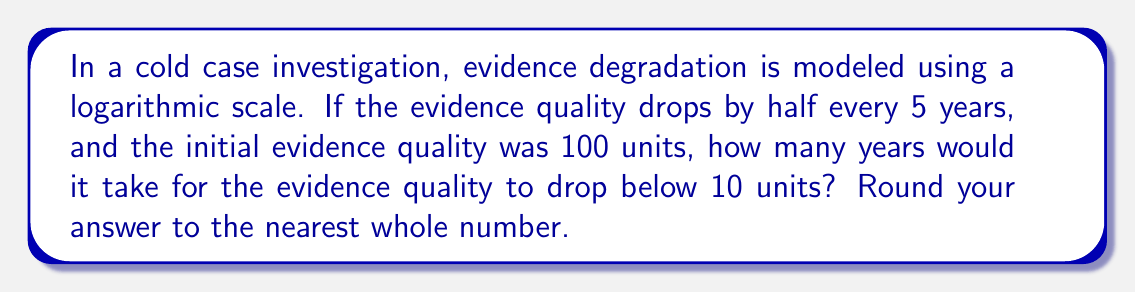Solve this math problem. Let's approach this step-by-step:

1) First, we need to establish our logarithmic model. The general form is:

   $Q(t) = Q_0 \cdot 2^{-t/h}$

   Where $Q(t)$ is the quality at time $t$, $Q_0$ is the initial quality, and $h$ is the half-life.

2) We're given:
   $Q_0 = 100$ (initial quality)
   $h = 5$ (half-life in years)

3) We want to find $t$ when $Q(t) < 10$. Let's set up the equation:

   $10 = 100 \cdot 2^{-t/5}$

4) Divide both sides by 100:

   $0.1 = 2^{-t/5}$

5) Take the logarithm (base 2) of both sides:

   $\log_2(0.1) = -t/5$

6) Solve for $t$:

   $t = -5 \log_2(0.1)$

7) Calculate:
   
   $t = -5 \cdot (-3.32192809488736)$
   $t \approx 16.6096404744368$

8) Rounding to the nearest whole number:

   $t \approx 17$ years
Answer: 17 years 